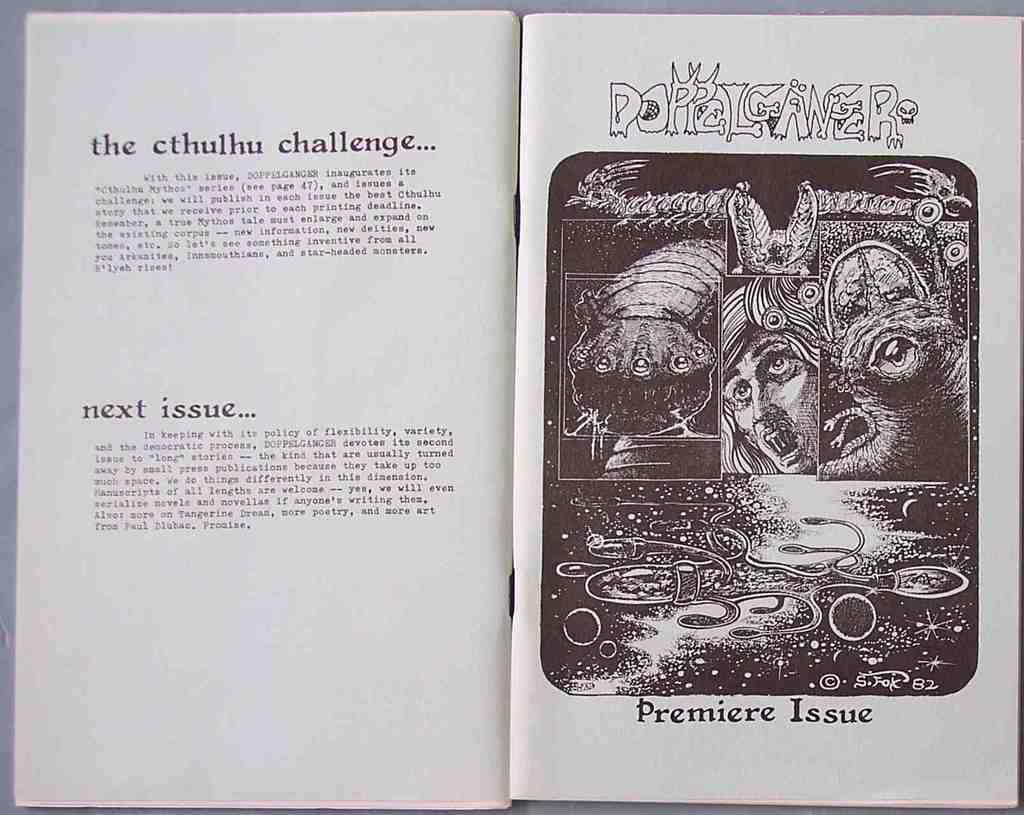<image>
Relay a brief, clear account of the picture shown. the words next issue are found on the left page 